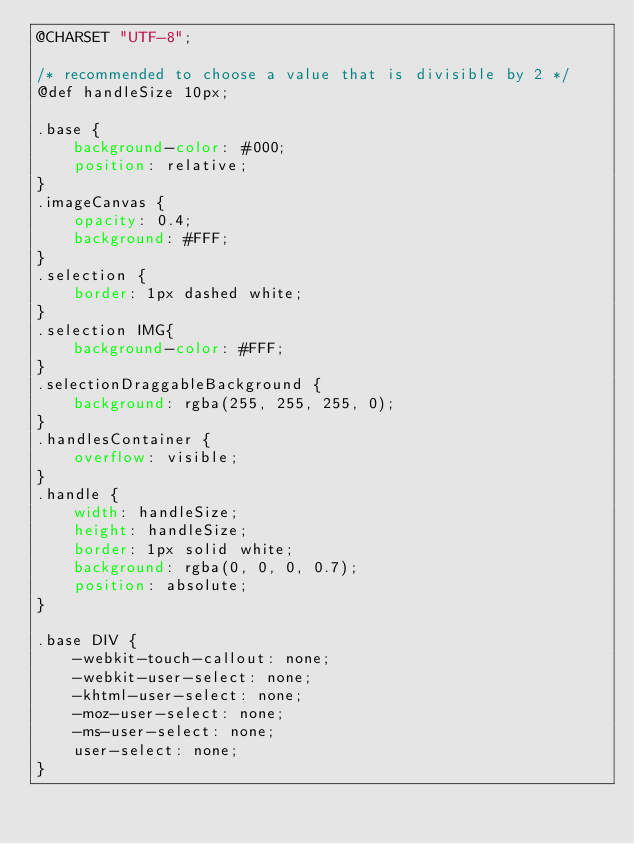<code> <loc_0><loc_0><loc_500><loc_500><_CSS_>@CHARSET "UTF-8";

/* recommended to choose a value that is divisible by 2 */
@def handleSize 10px;

.base {
	background-color: #000;
	position: relative;
}
.imageCanvas {
	opacity: 0.4;
	background: #FFF;
}
.selection {
	border: 1px dashed white;
}
.selection IMG{
	background-color: #FFF;
}
.selectionDraggableBackground {
    background: rgba(255, 255, 255, 0);
}
.handlesContainer {
	overflow: visible;
}
.handle {
	width: handleSize;
	height: handleSize;
	border: 1px solid white;
	background: rgba(0, 0, 0, 0.7);
	position: absolute;
}

.base DIV {
	-webkit-touch-callout: none;
	-webkit-user-select: none;
	-khtml-user-select: none;
	-moz-user-select: none;
	-ms-user-select: none;
	user-select: none;
}</code> 